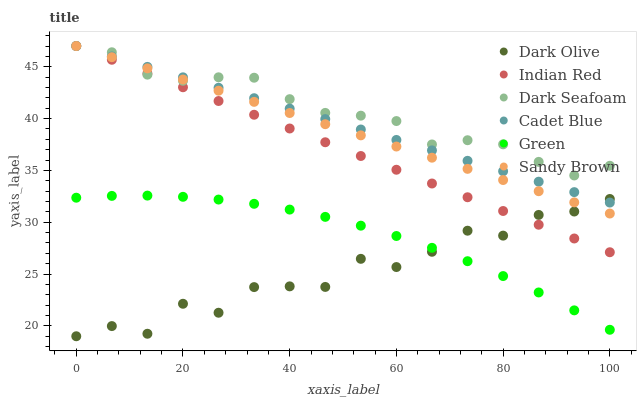Does Dark Olive have the minimum area under the curve?
Answer yes or no. Yes. Does Dark Seafoam have the maximum area under the curve?
Answer yes or no. Yes. Does Dark Seafoam have the minimum area under the curve?
Answer yes or no. No. Does Dark Olive have the maximum area under the curve?
Answer yes or no. No. Is Indian Red the smoothest?
Answer yes or no. Yes. Is Dark Olive the roughest?
Answer yes or no. Yes. Is Dark Seafoam the smoothest?
Answer yes or no. No. Is Dark Seafoam the roughest?
Answer yes or no. No. Does Dark Olive have the lowest value?
Answer yes or no. Yes. Does Dark Seafoam have the lowest value?
Answer yes or no. No. Does Sandy Brown have the highest value?
Answer yes or no. Yes. Does Dark Olive have the highest value?
Answer yes or no. No. Is Green less than Indian Red?
Answer yes or no. Yes. Is Sandy Brown greater than Green?
Answer yes or no. Yes. Does Cadet Blue intersect Dark Seafoam?
Answer yes or no. Yes. Is Cadet Blue less than Dark Seafoam?
Answer yes or no. No. Is Cadet Blue greater than Dark Seafoam?
Answer yes or no. No. Does Green intersect Indian Red?
Answer yes or no. No. 